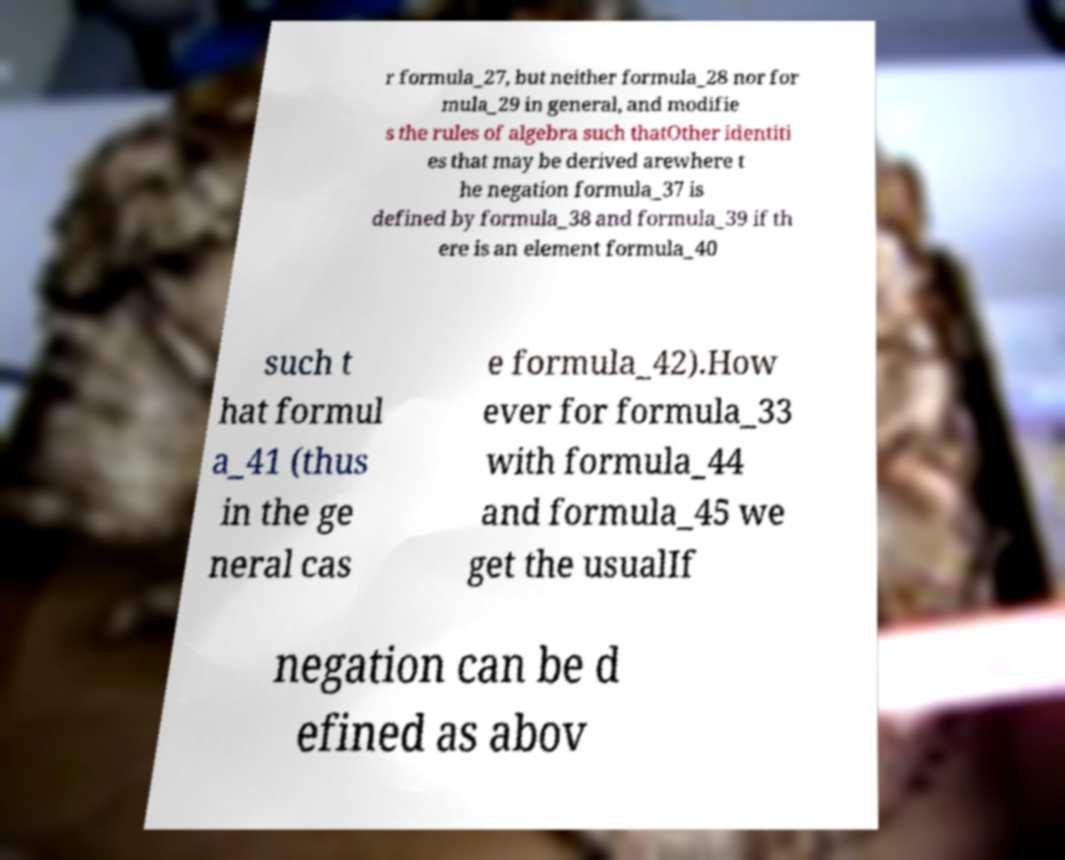Please identify and transcribe the text found in this image. r formula_27, but neither formula_28 nor for mula_29 in general, and modifie s the rules of algebra such thatOther identiti es that may be derived arewhere t he negation formula_37 is defined by formula_38 and formula_39 if th ere is an element formula_40 such t hat formul a_41 (thus in the ge neral cas e formula_42).How ever for formula_33 with formula_44 and formula_45 we get the usualIf negation can be d efined as abov 